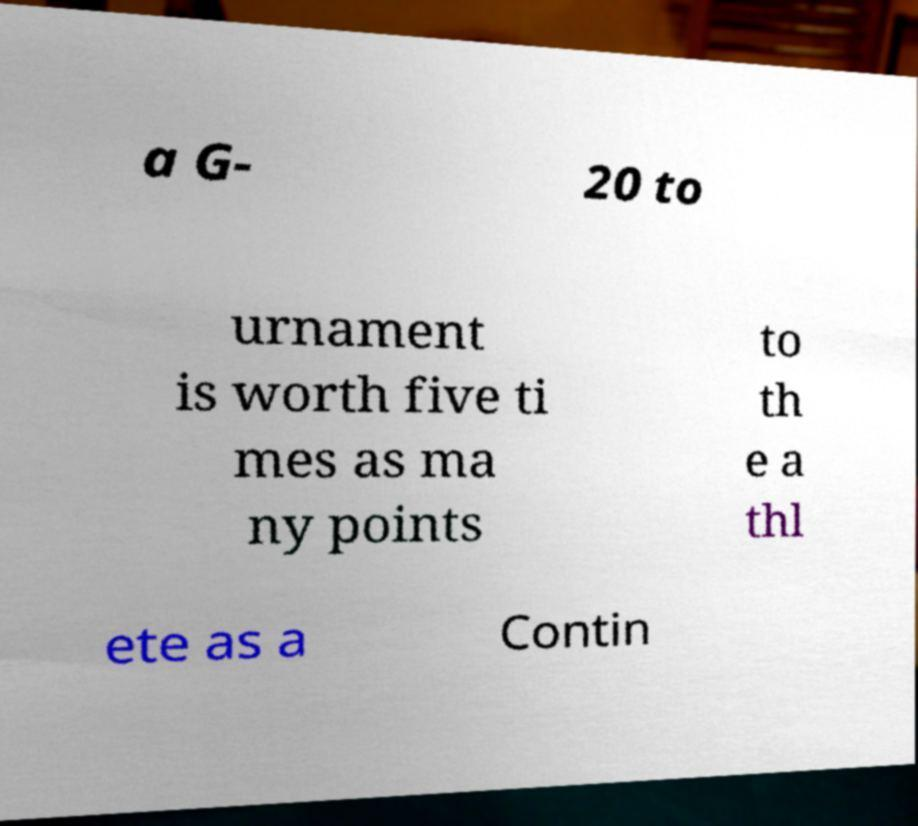For documentation purposes, I need the text within this image transcribed. Could you provide that? a G- 20 to urnament is worth five ti mes as ma ny points to th e a thl ete as a Contin 